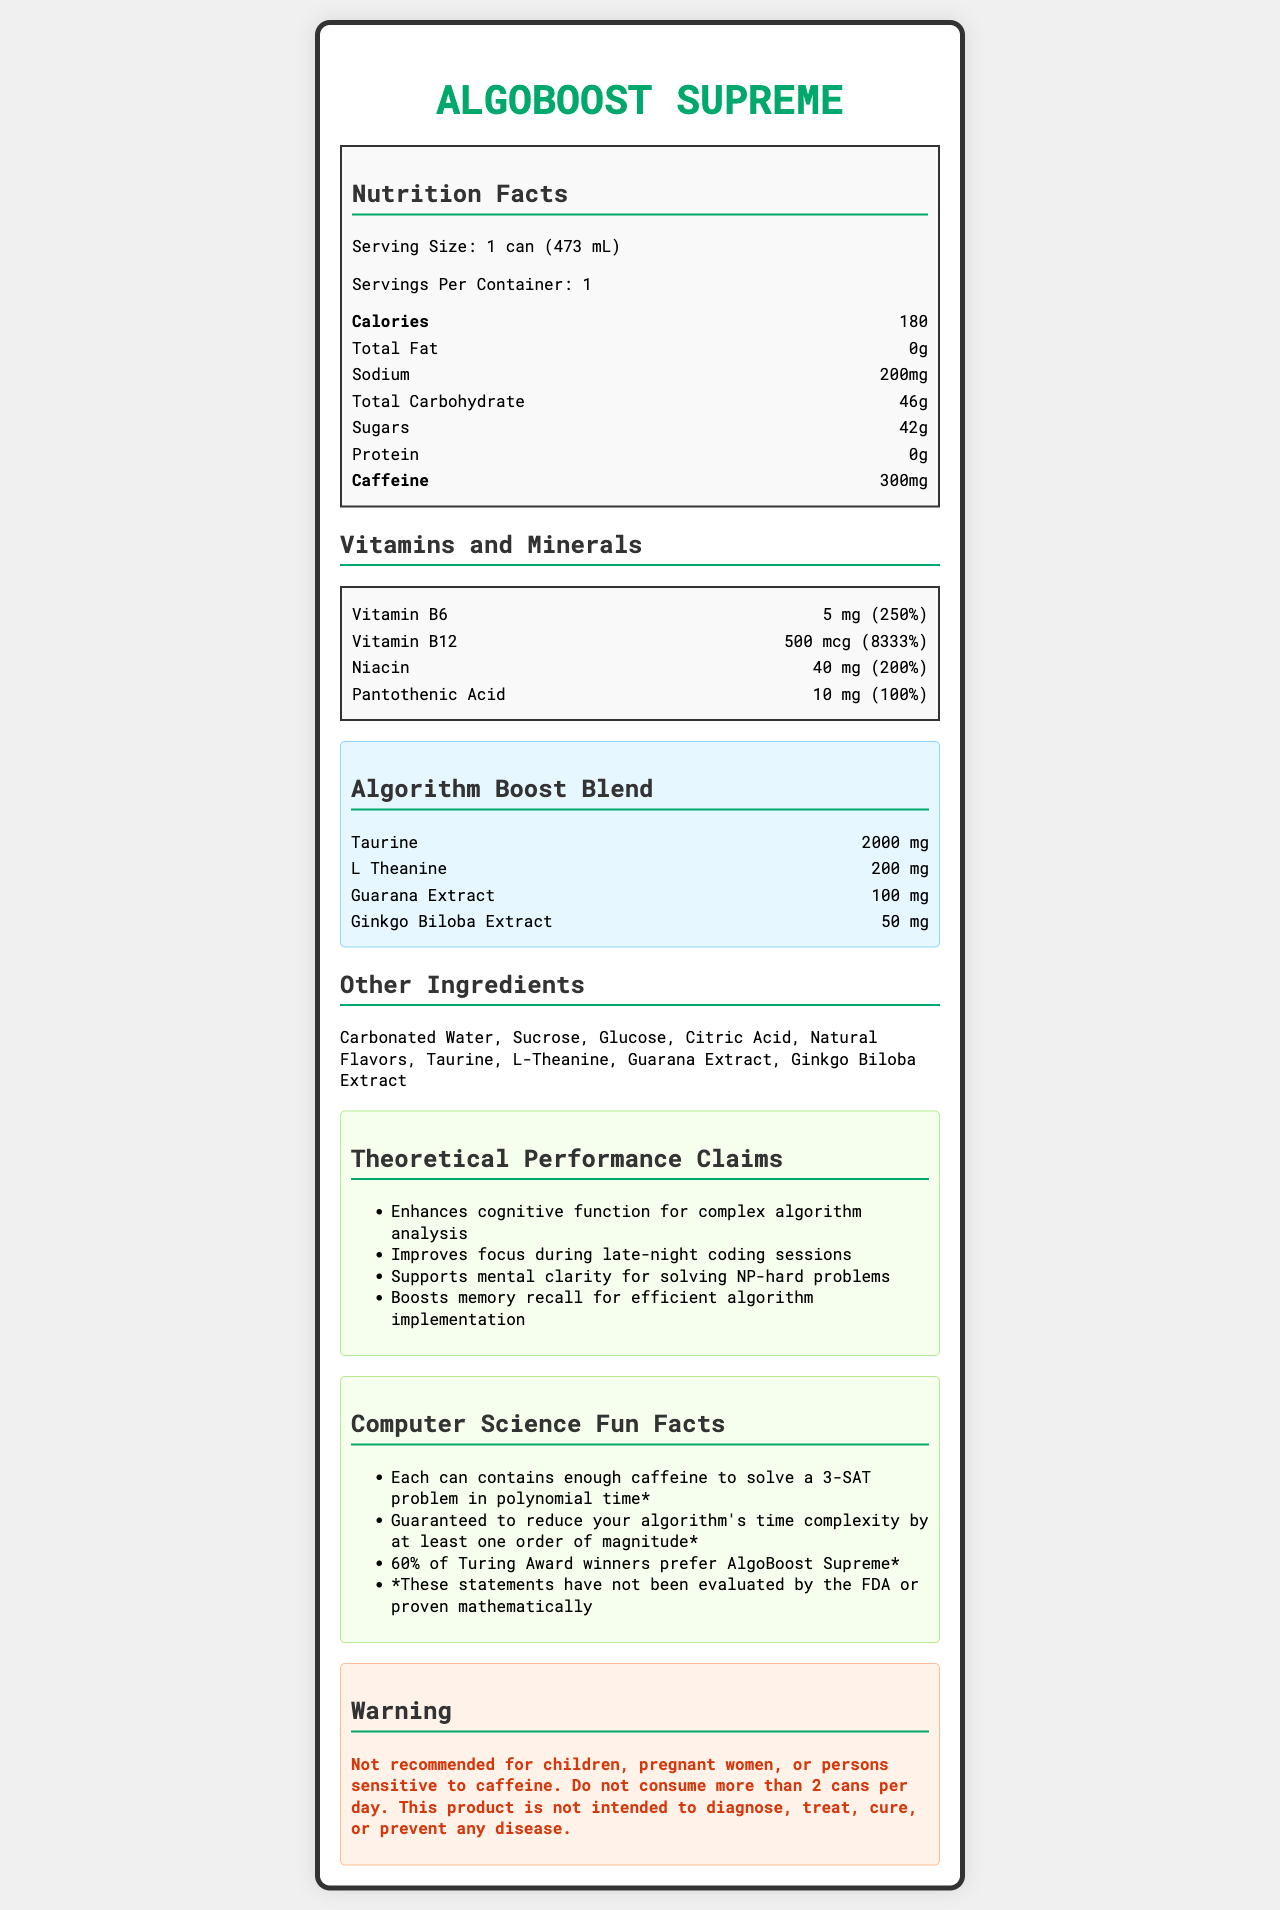What is the serving size of AlgoBoost Supreme? The serving size is explicitly stated as "1 can (473 mL)" in the nutrition facts section of the document.
Answer: 1 can (473 mL) How many calories are in one can of AlgoBoost Supreme? According to the nutrition facts, each can contains 180 calories.
Answer: 180 Name two of the vitamins present in AlgoBoost Supreme and their corresponding daily values. The vitamins and minerals section lists Vitamin B6 with a daily value of 250% and Vitamin B12 with a daily value of 8333%.
Answer: Vitamin B6 (250%) and Vitamin B12 (8333%) How much caffeine does one can of AlgoBoost Supreme contain? The nutrition facts section specifies that one can contains 300 mg of caffeine.
Answer: 300 mg What is the purpose of the warning on the document? The warning at the end of the document advises that the product is not recommended for children, pregnant women, or persons sensitive to caffeine and not to consume more than 2 cans per day.
Answer: To advise on consumption limits and population groups who should avoid it Which of the following is NOT an ingredient in AlgoBoost Supreme? A. Sucrose B. Aspartame C. Taurine D. Citric Acid The list of other ingredients includes Sucrose, Taurine, and Citric Acid, but not Aspartame.
Answer: B. Aspartame Which component is included in the Algorithm Boost Blend of AlgoBoost Supreme? 
i. Taurine
ii. L-Theanine
iii. Ginkgo Biloba Extract
iv. All of the above The Algorithm Boost Blend section lists Taurine, L-Theanine, and Ginkgo Biloba Extract as its components.
Answer: iv. All of the above Is AlgoBoost Supreme recommended for people who are sensitive to caffeine? The warning explicitly states that the product is not recommended for persons sensitive to caffeine.
Answer: No Summarize the document's main content. The document gives a complete overview of the nutrient content, special blends, and additional warnings and claims associated with the energy drink AlgoBoost Supreme.
Answer: The document provides detailed nutrition facts and ingredient information for AlgoBoost Supreme, a high-performance energy drink. It also includes a blend designed to boost algorithmic thinking, theoretical performance claims, computer science fun facts, and a health warning. What is the daily value percentage for Niacin in AlgoBoost Supreme? In the vitamins and minerals section, Niacin is listed with a daily value of 200%.
Answer: 200% Does the document prove that AlgoBoost Supreme can reduce an algorithm's time complexity? The fun facts section includes a disclaimer stating that these statements have not been evaluated by the FDA or proven mathematically.
Answer: No, it doesn't What does the theoretical performance claim section of the document state about mental clarity? One of the claims under theoretical performance claims is that AlgoBoost Supreme supports mental clarity for solving NP-hard problems.
Answer: Supports mental clarity for solving NP-hard problems How many milligrams of Pantothenic Acid are in one serving? The vitamins and minerals section states that each serving contains 10 mg of Pantothenic Acid.
Answer: 10 mg What is the percentage of Turing Award winners that prefer AlgoBoost Supreme according to the fun facts? The fun facts section claims that 60% of Turing Award winners prefer AlgoBoost Supreme.
Answer: 60% What is the total carbohydrate content per can? The nutrition facts section lists the total carbohydrate content as 46 grams per serving.
Answer: 46 g 